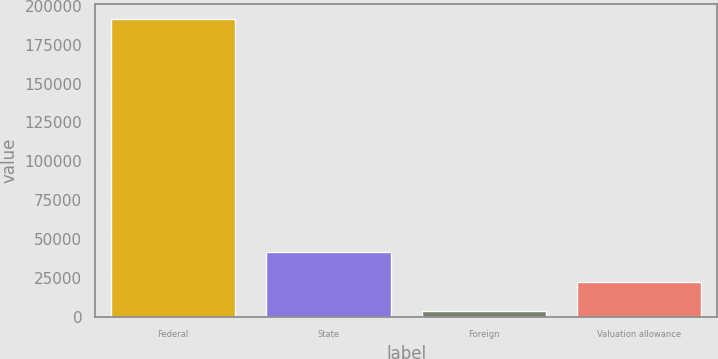Convert chart. <chart><loc_0><loc_0><loc_500><loc_500><bar_chart><fcel>Federal<fcel>State<fcel>Foreign<fcel>Valuation allowance<nl><fcel>191596<fcel>41560.8<fcel>4052<fcel>22806.4<nl></chart> 